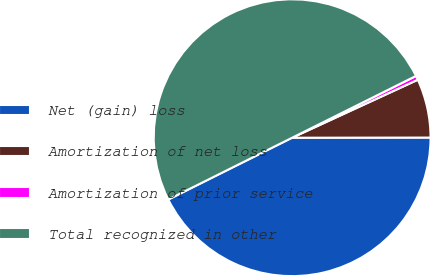<chart> <loc_0><loc_0><loc_500><loc_500><pie_chart><fcel>Net (gain) loss<fcel>Amortization of net loss<fcel>Amortization of prior service<fcel>Total recognized in other<nl><fcel>42.65%<fcel>6.86%<fcel>0.49%<fcel>50.0%<nl></chart> 